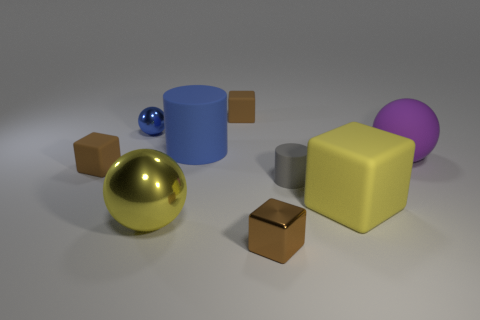Subtract all shiny blocks. How many blocks are left? 3 Add 1 big blue cylinders. How many objects exist? 10 Subtract all blocks. How many objects are left? 5 Subtract all yellow blocks. How many blocks are left? 3 Subtract all cyan spheres. Subtract all red cylinders. How many spheres are left? 3 Subtract all green cylinders. How many brown cubes are left? 3 Subtract all yellow cubes. Subtract all small gray things. How many objects are left? 7 Add 5 large blue things. How many large blue things are left? 6 Add 6 tiny gray cylinders. How many tiny gray cylinders exist? 7 Subtract 0 red balls. How many objects are left? 9 